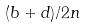Convert formula to latex. <formula><loc_0><loc_0><loc_500><loc_500>( b + d ) / 2 n</formula> 